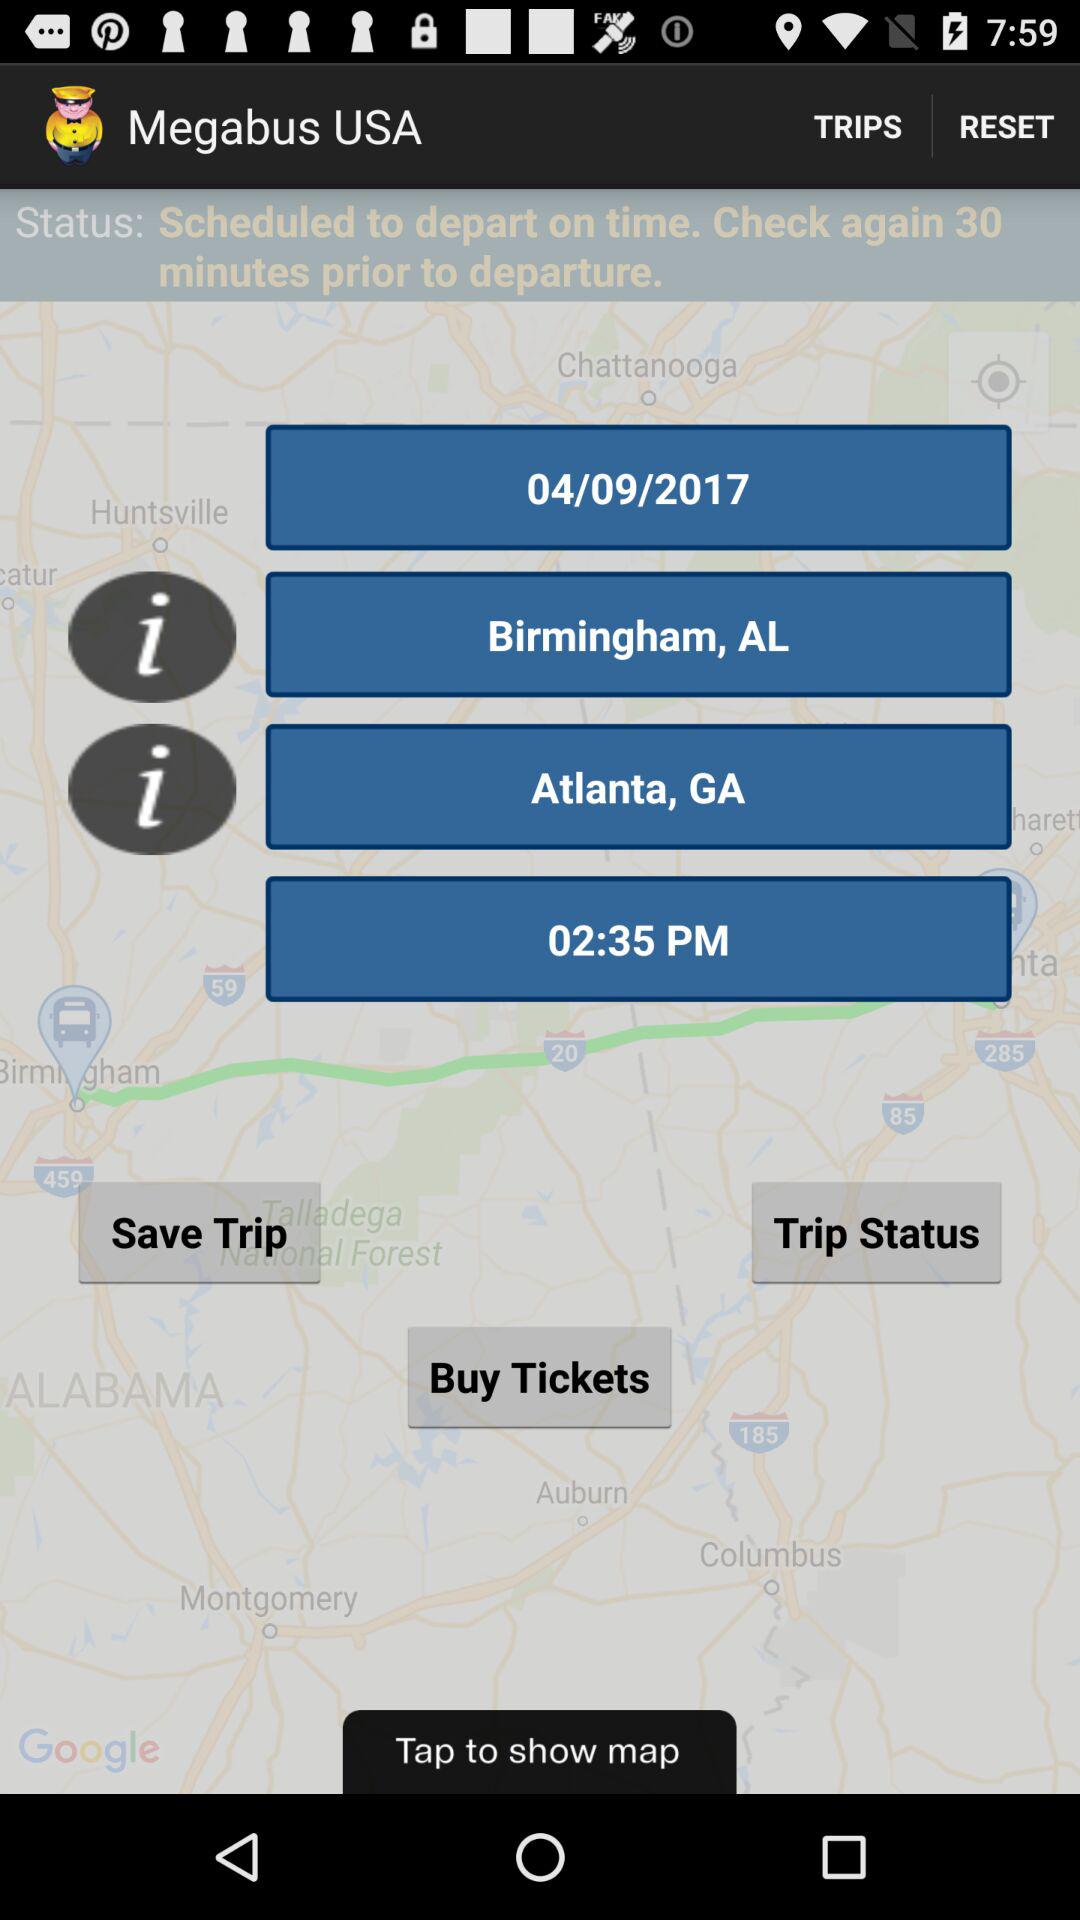What's the shown date? The shown date is 04/09/2017. 